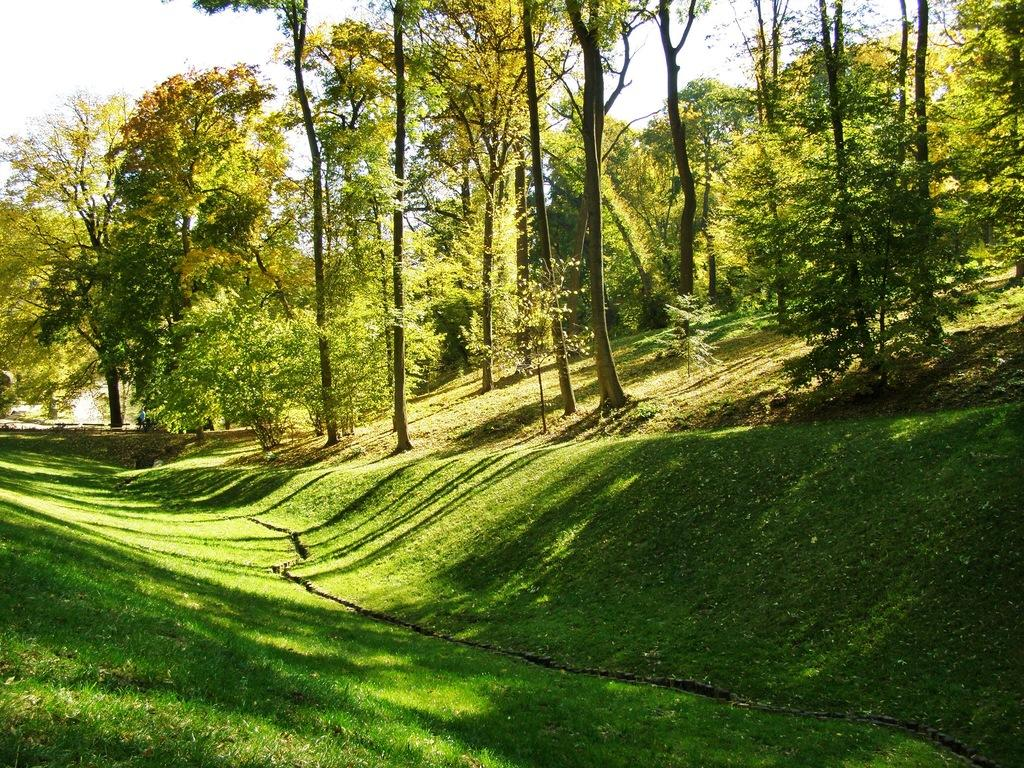What type of vegetation is present in the image? There are many trees, plants, and grass in the image. What is visible in the top left corner of the image? The sky is visible in the top left corner of the image. What geographical feature can be seen on the right side of the image? There is a mountain on the right side of the image. What type of note is the person holding while embarking on a voyage in the image? There is no person holding a note or embarking on a voyage in the image; it primarily features natural elements such as trees, plants, grass, sky, and a mountain. 